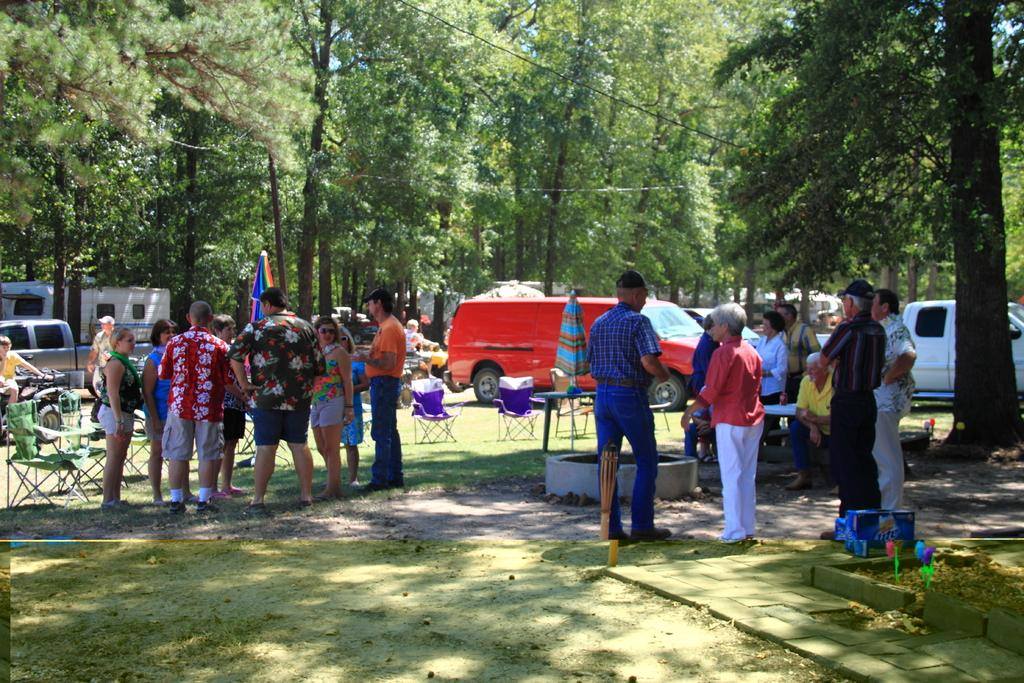How many people can be seen in the image? There are people in the image, but the exact number is not specified. What type of furniture is present in the image? There are chairs in the image. What is on the table in the image? There is an object on the table. What type of natural environment is visible in the image? There is grass visible in the image. What type of transportation is present in the image? There are vehicles in the image. What type of protection from the sun is present in the image? There are umbrellas in the image. What other objects can be seen in the image? There are other objects in the image, but their specific nature is not mentioned. What can be seen in the background of the image? There are trees and sky visible in the background of the image. What type of tools does the carpenter use in the image? There is no carpenter present in the image, so no tools can be observed. What type of vacation is depicted in the image? There is no vacation depicted in the image; it features people, chairs, a table, grass, vehicles, umbrellas, and other objects. --- Facts: 1. There is a person in the image. 2. The person is holding a book. 3. The person is sitting on a chair. 4. There is a table in the image. 5. There is a lamp on the table. 6. There is a window in the image. 7. There is a curtain associated with the window. 8. There is a plant on the windowsill. Absurd Topics: elephant, parachute, ocean Conversation: What is the person in the image doing? The person in the image is holding a book. What type of furniture is present in the image? The person is sitting on a chair. What is on the table in the image? There is a lamp on the table. What can be seen through the window in the image? There is a plant on the windowsill. What type of window treatment is present in the image? There is a curtain associated with the window. Reasoning: Let's think step by step in order to produce the conversation. We start by identifying the main subject in the image, which is the person holding a book. Then, we expand the conversation to include other items that are also visible, such as the chair, table, lamp, window, curtain, and plant. Each question is designed to elicit a specific detail about the image that is known from the provided facts. Absurd Question/Answer: Can you see an elephant jumping out of a parachute over the ocean in the image? No, there is no elephant, parachute, or ocean present in the image. 